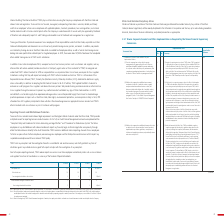From Taiwan Semiconductor Manufacturing Co's financial document, Which process allow employees or any whistleblowers with relevant evidence to report any financial, legal, or ethical irregularities anonymously? The document shows two values: “Complaint Policy and Procedures for Certain Accounting and Legal Matters” and “Procedures for Ombudsman System”. From the document: "ures for Certain Accounting and Legal Matters” and “Procedures for Ombudsman System” that allow employees or any whistleblowers with relevant evidence..." Also, What was the total reported cases in FY 16? According to the financial document, 116. The relevant text states: "Total reported cases 116 113 150 205 (Note 1)..." Also, How many cases were reported related to employee relationship in 2019? According to the financial document, 132. The relevant text states: "Note 1: Among the 205 cases, 132 were related to employee relationship, 47 cases related to other matters (e.g. employee’s individua..." Also, can you calculate: What is the change in Total reported cases from FY 2016 to FY 2017? Based on the calculation: 113-116, the result is -3. This is based on the information: "Total reported cases 116 113 150 205 (Note 1) Total reported cases 116 113 150 205 (Note 1)..." The key data points involved are: 113, 116. Also, can you calculate: What is the change in Ethics-related cases between FY 2016 and FY 2017? Based on the calculation: 20-16, the result is 4. This is based on the information: "Year FY 2016 FY 2017 FY 2018 FY2019 Year FY 2016 FY 2017 FY 2018 FY2019..." The key data points involved are: 16, 20. Also, can you calculate: What is the change in Cases investigated and verified as ethics violations between FY 2016 and FY 2017? Based on the calculation: 4-2, the result is 2. This is based on the information: "Ethics-related cases 16 20 14 26 Ethics-related cases 16 20 14 26..." The key data points involved are: 4. 